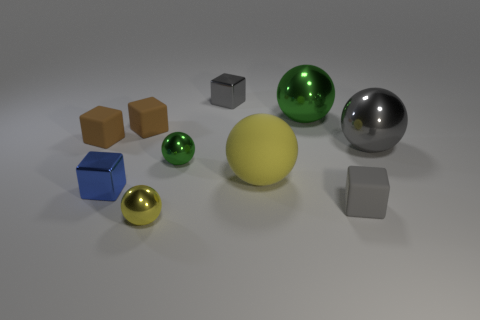What reflections can be seen in the larger spherical objects? The larger spherical objects exhibit reflective surfaces that mirror the studio environment. Their surfaces capture highlights and reflections that convey the shape of unseen light sources and subtly reflect other objects present within the scene. Is there anything that seems out of place or unusual among these objects? Upon closer inspection, all objects seem to be appropriately placed as part of a 3D rendering composition, designed to showcase different materials and their interaction with light. There's nothing particularly out of place, as each object serves the purpose of a rendering test scene. 